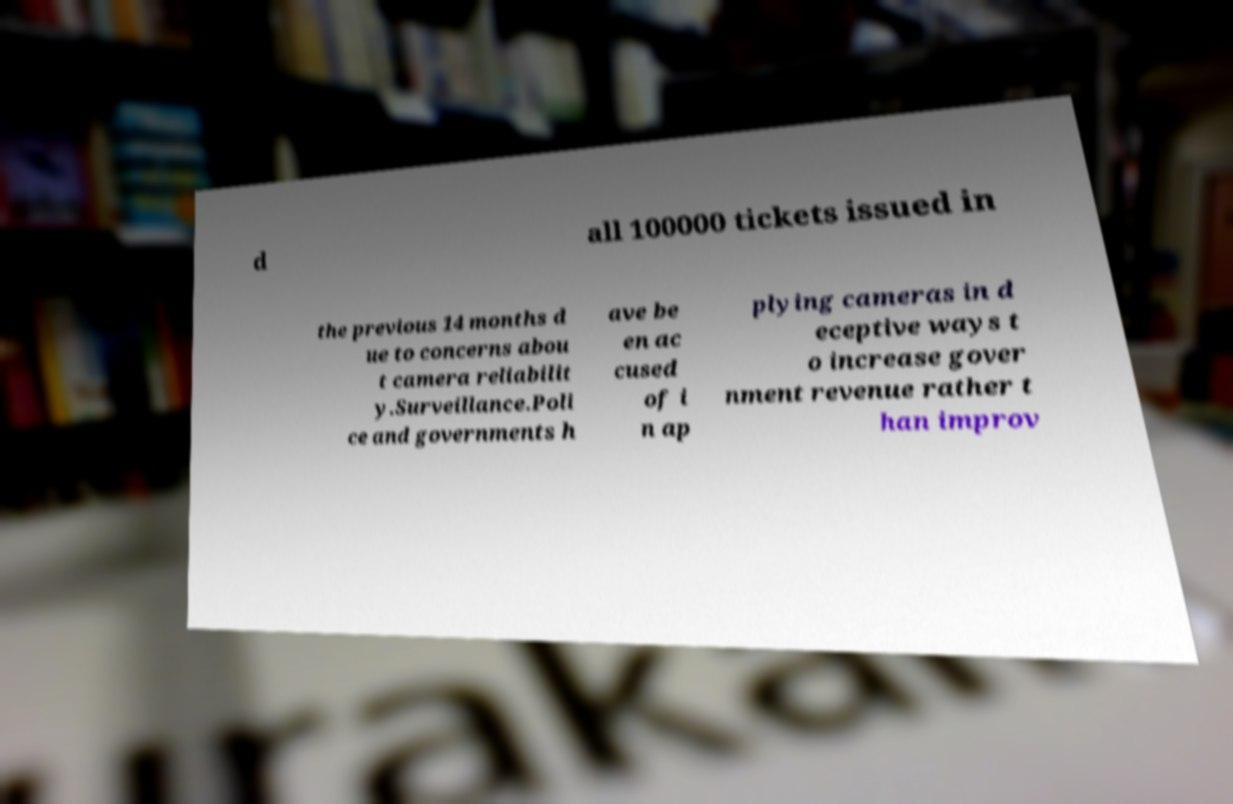Can you accurately transcribe the text from the provided image for me? d all 100000 tickets issued in the previous 14 months d ue to concerns abou t camera reliabilit y.Surveillance.Poli ce and governments h ave be en ac cused of i n ap plying cameras in d eceptive ways t o increase gover nment revenue rather t han improv 